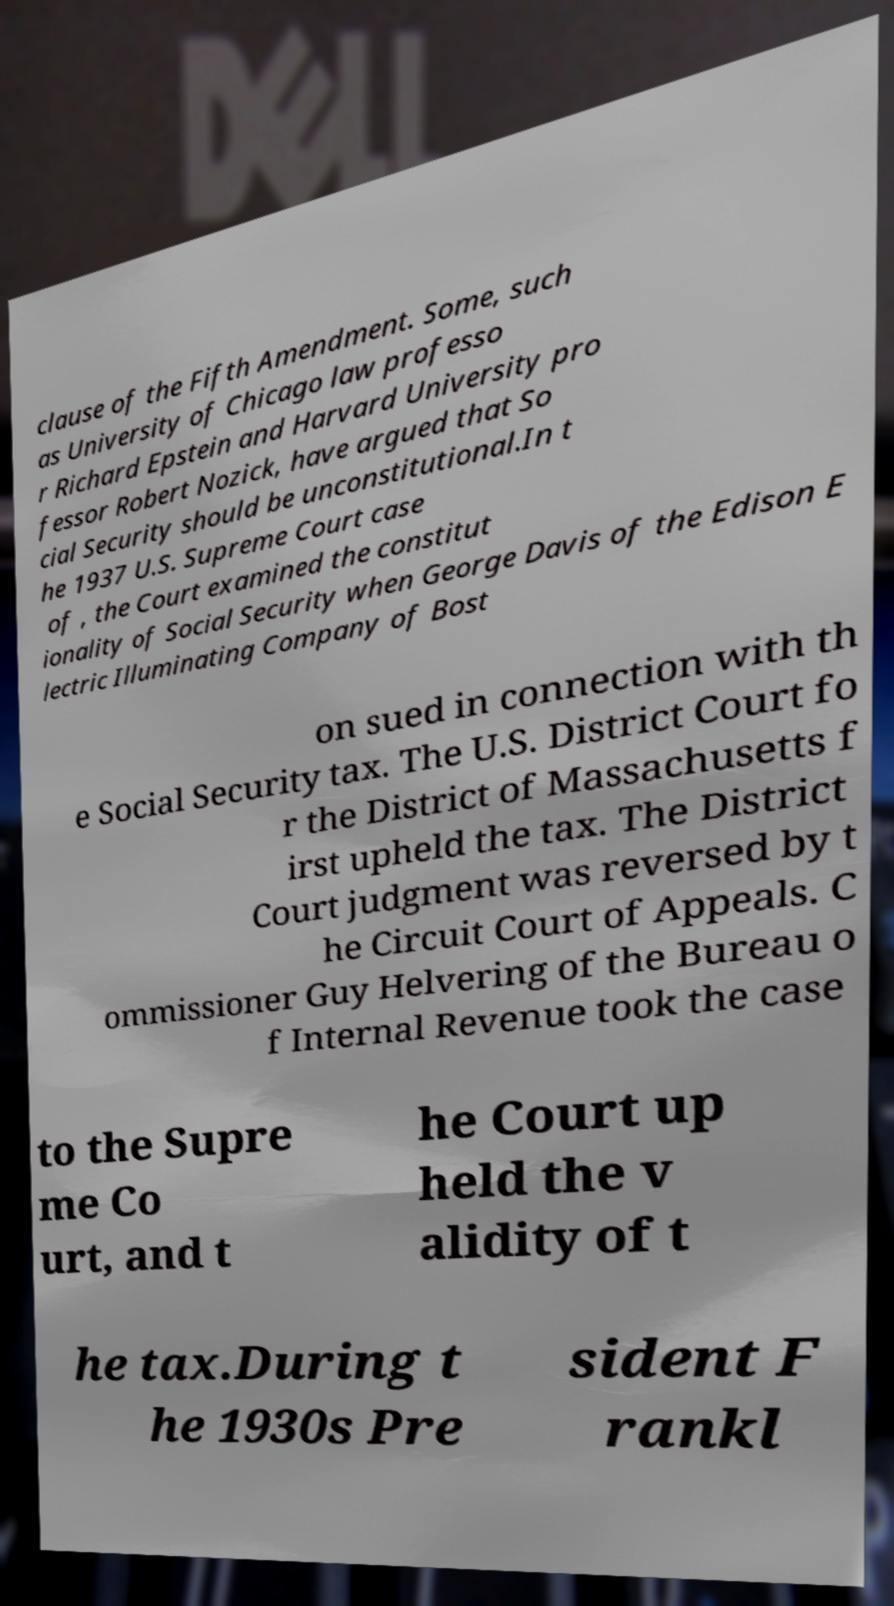Please identify and transcribe the text found in this image. clause of the Fifth Amendment. Some, such as University of Chicago law professo r Richard Epstein and Harvard University pro fessor Robert Nozick, have argued that So cial Security should be unconstitutional.In t he 1937 U.S. Supreme Court case of , the Court examined the constitut ionality of Social Security when George Davis of the Edison E lectric Illuminating Company of Bost on sued in connection with th e Social Security tax. The U.S. District Court fo r the District of Massachusetts f irst upheld the tax. The District Court judgment was reversed by t he Circuit Court of Appeals. C ommissioner Guy Helvering of the Bureau o f Internal Revenue took the case to the Supre me Co urt, and t he Court up held the v alidity of t he tax.During t he 1930s Pre sident F rankl 